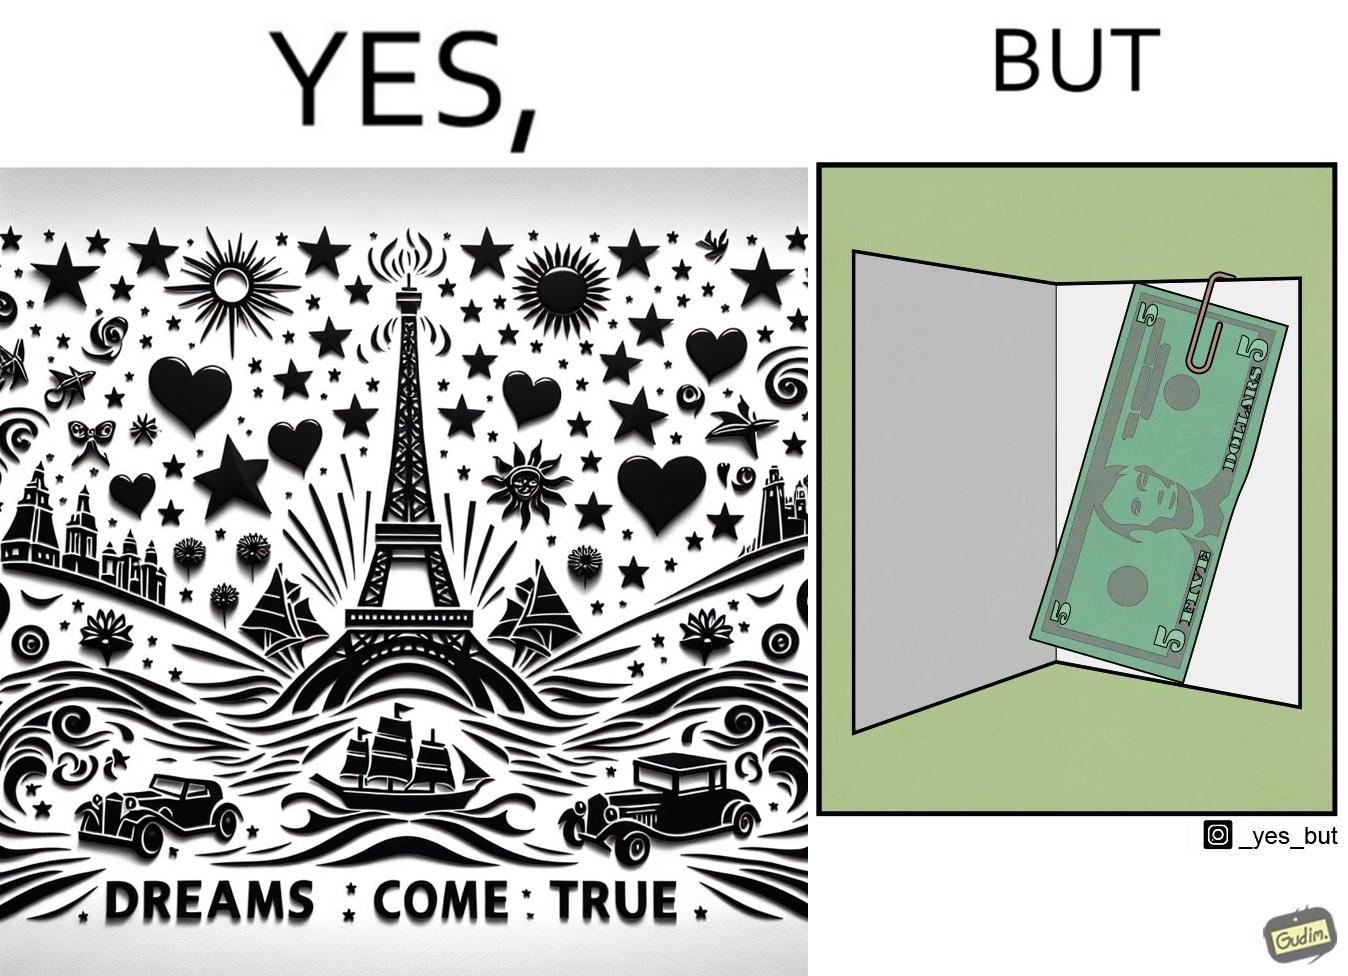Describe the content of this image. The overall image is funny because while the front of the card gives hope that the person receiving this card will have one of their dreams come true but opening the card reveals only 5 dollars which is nowhere enough to fulfil any kind of dream. 